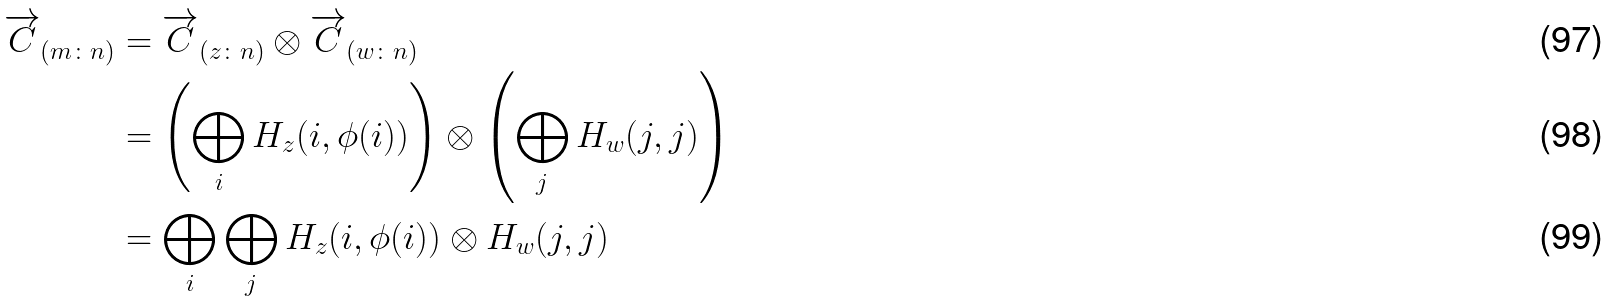<formula> <loc_0><loc_0><loc_500><loc_500>\overrightarrow { C } _ { ( m \colon n ) } & = \overrightarrow { C } _ { ( z \colon n ) } \otimes \overrightarrow { C } _ { ( w \colon n ) } \\ & = \left ( \bigoplus _ { i } H _ { z } ( i , \phi ( i ) ) \right ) \otimes \left ( \bigoplus _ { j } H _ { w } ( j , j ) \right ) \\ & = \bigoplus _ { i } \bigoplus _ { j } H _ { z } ( i , \phi ( i ) ) \otimes H _ { w } ( j , j )</formula> 